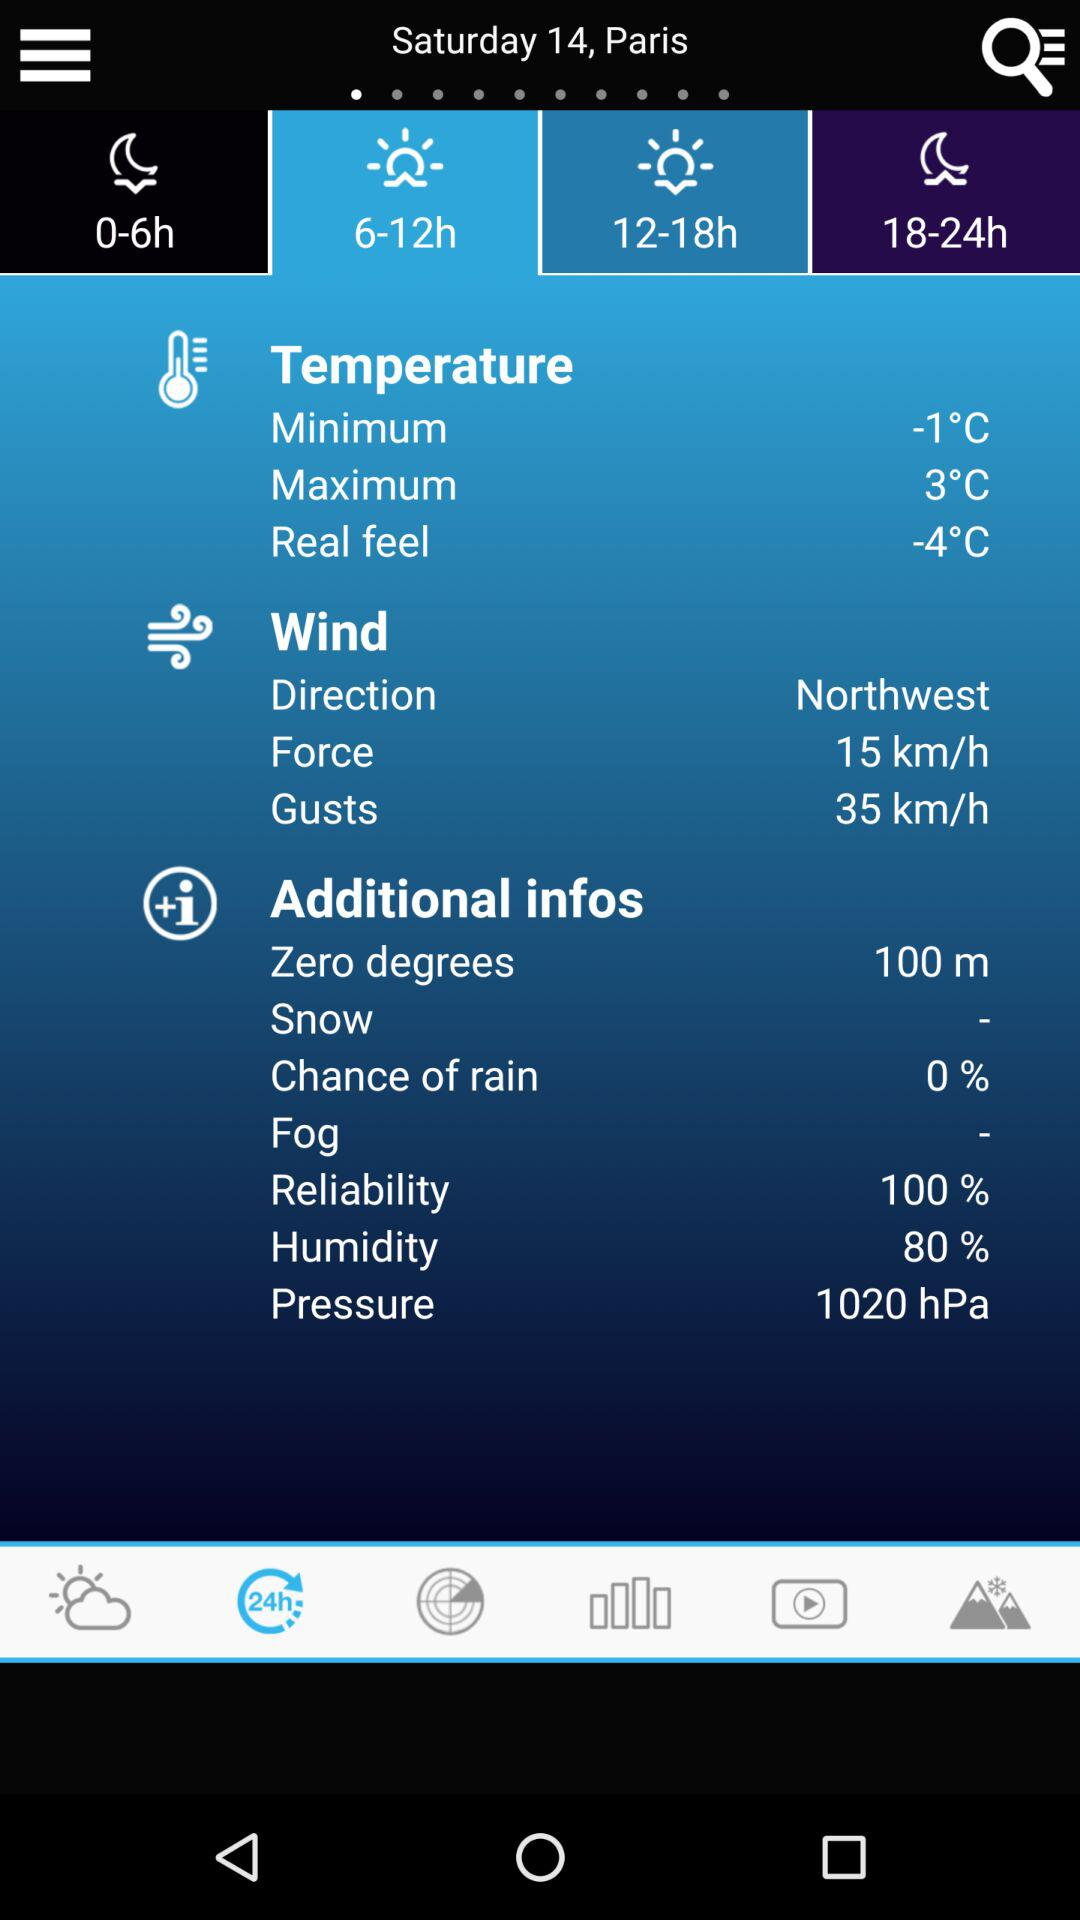What is the real feel temperature? The real feel temperature is -4 °C. 